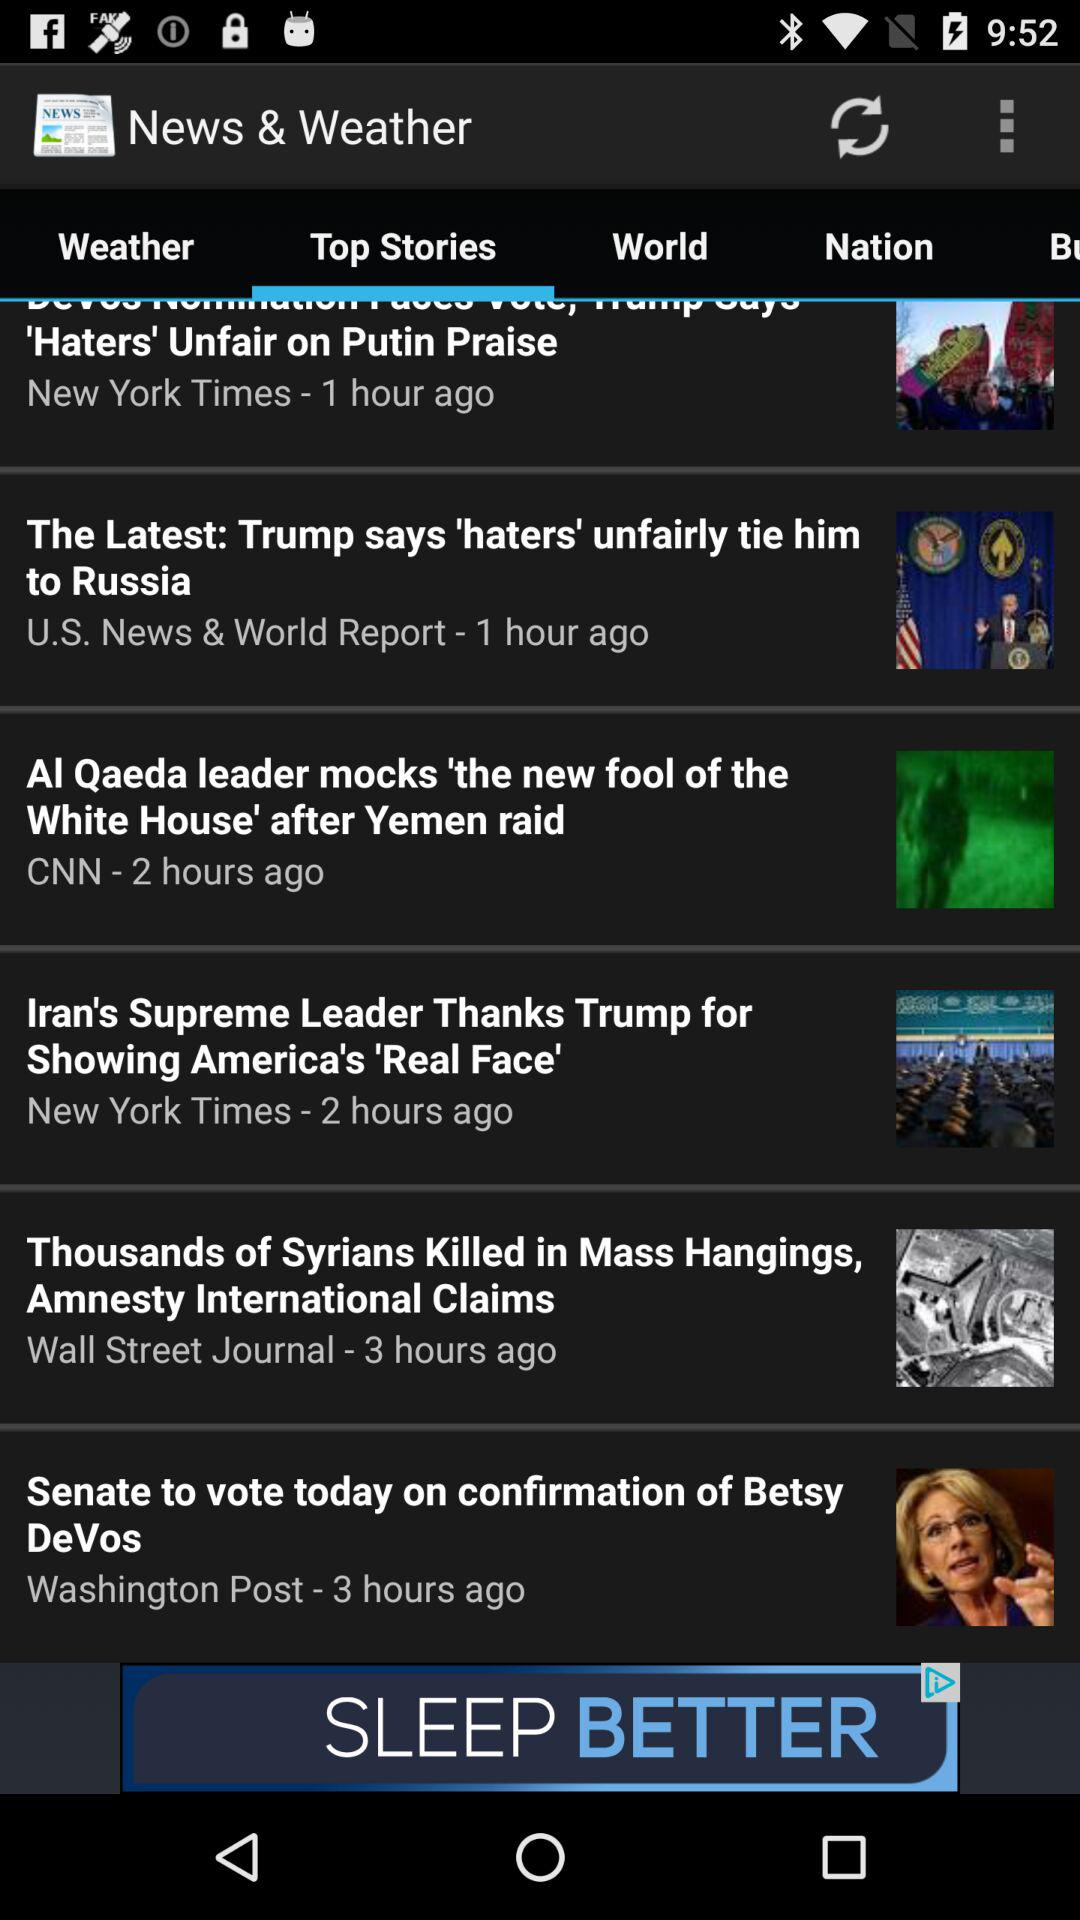How many more hours ago was the latest article posted than the oldest article?
Answer the question using a single word or phrase. 2 